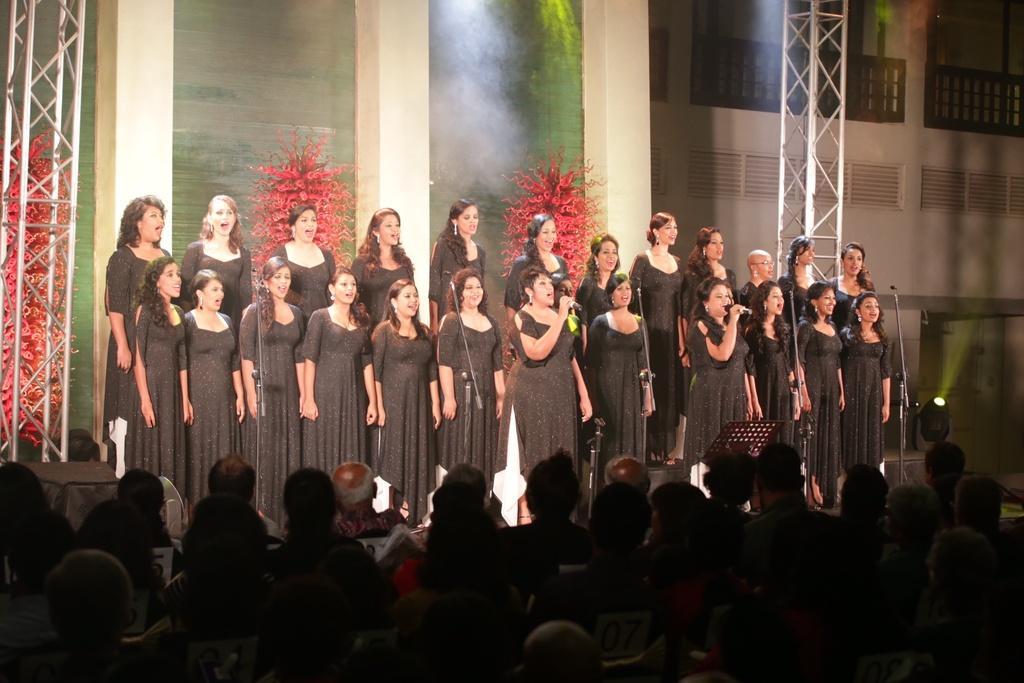Please provide a concise description of this image. At the bottom of this image, there are persons, sitting. In the background, there are women singing and standing on a stage, there are pillars, decorative items and a wall of a building. 